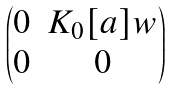<formula> <loc_0><loc_0><loc_500><loc_500>\begin{pmatrix} 0 & K _ { 0 } [ a ] w \\ 0 & 0 \end{pmatrix}</formula> 